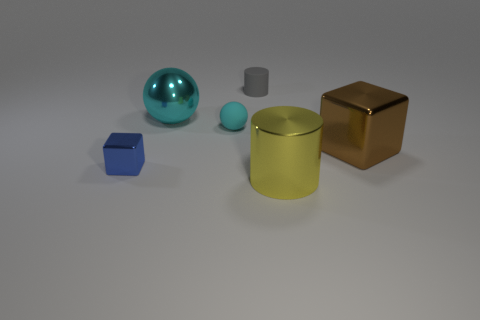Add 2 small purple matte blocks. How many objects exist? 8 Subtract all balls. How many objects are left? 4 Add 2 large brown metallic cubes. How many large brown metallic cubes are left? 3 Add 5 cyan rubber things. How many cyan rubber things exist? 6 Subtract 0 brown cylinders. How many objects are left? 6 Subtract all cyan metal cubes. Subtract all brown objects. How many objects are left? 5 